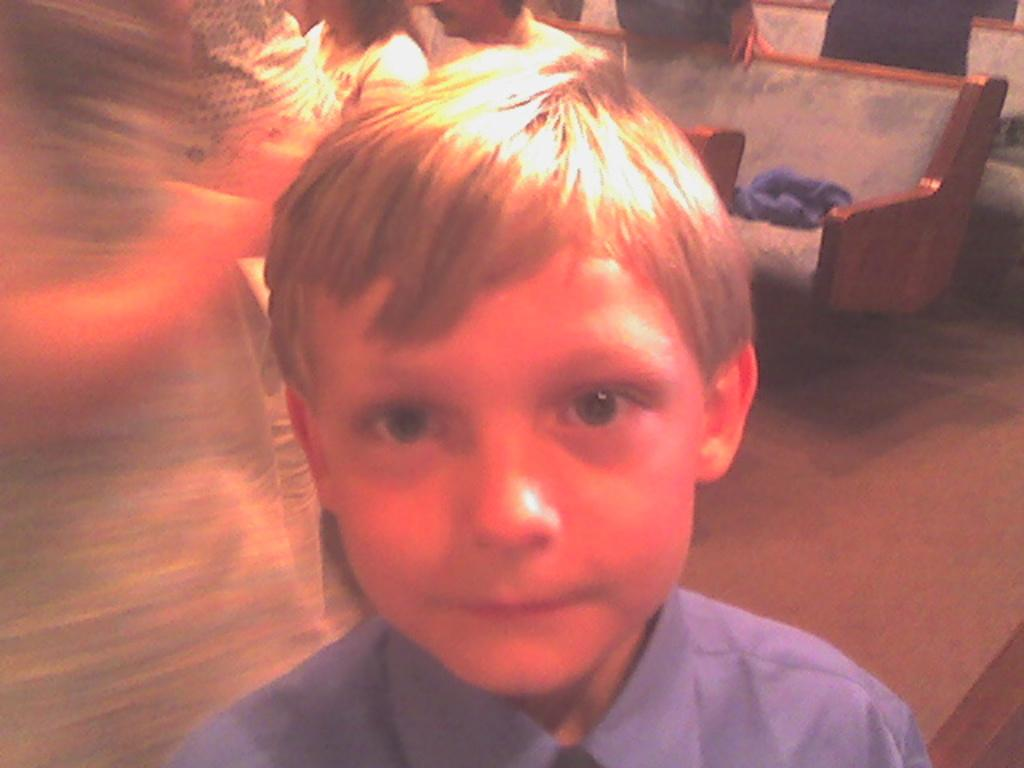What is the main subject in the foreground of the picture? There is a boy in the foreground of the picture. What can be seen in the background of the picture? There are persons sitting on a couch in the background of the picture. What is the tendency of the girls in the picture to perform operations? There are no girls or operations mentioned in the image, so it is not possible to determine any tendencies related to them. 